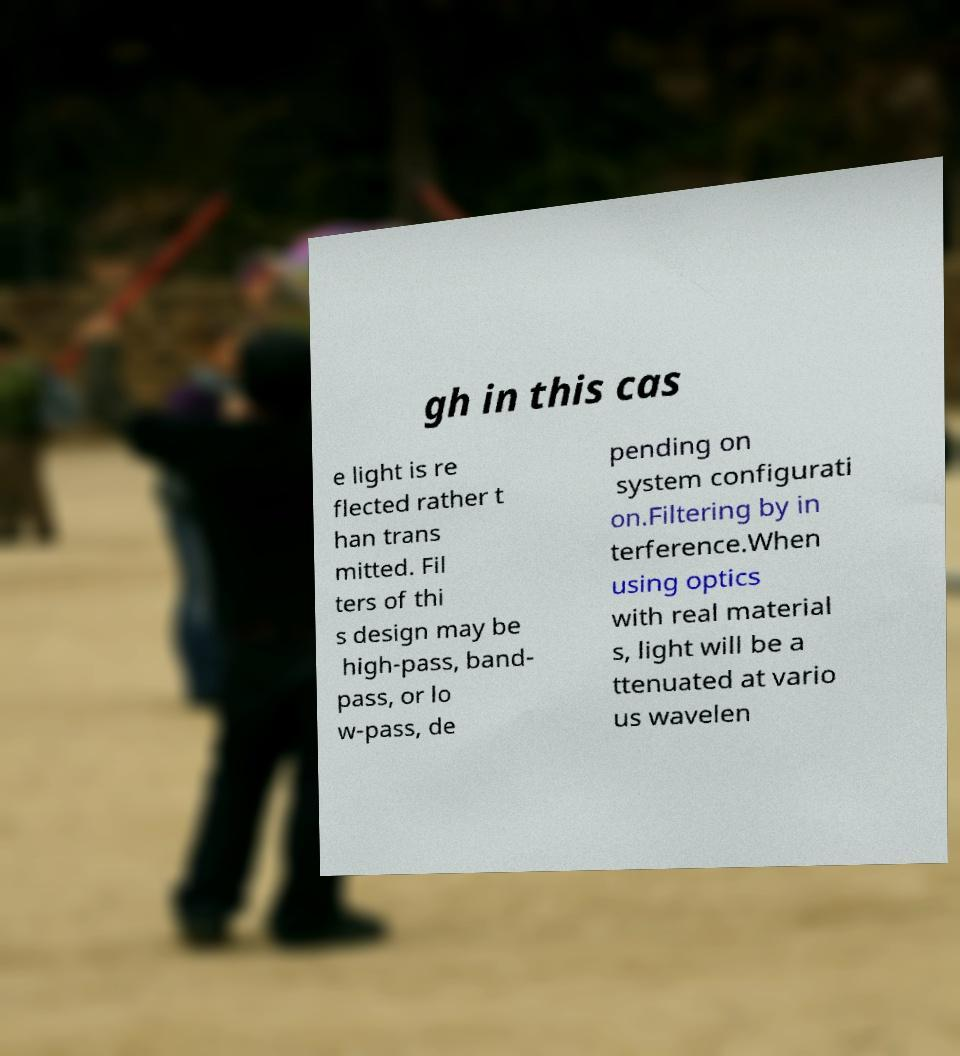Can you read and provide the text displayed in the image?This photo seems to have some interesting text. Can you extract and type it out for me? gh in this cas e light is re flected rather t han trans mitted. Fil ters of thi s design may be high-pass, band- pass, or lo w-pass, de pending on system configurati on.Filtering by in terference.When using optics with real material s, light will be a ttenuated at vario us wavelen 